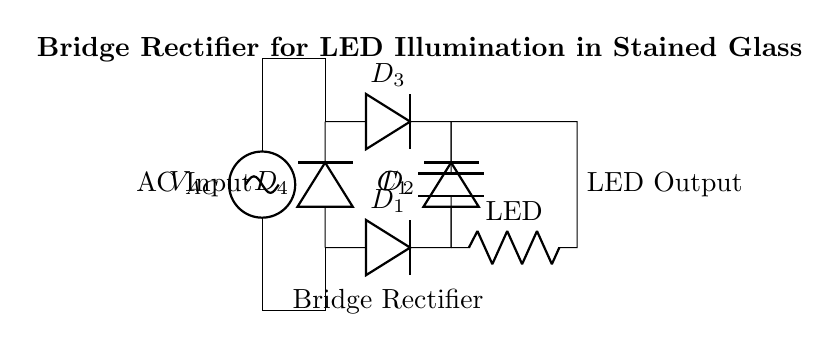What type of rectifier is shown? The circuit diagram depicts a bridge rectifier, which is characterized by four diodes arranged in a bridge configuration to convert AC to DC.
Answer: Bridge rectifier How many diodes are present in the circuit? The circuit includes four diodes: D1, D2, D3, and D4, which are part of the bridge rectifier configuration.
Answer: Four What component smooths the output voltage? The capacitor labeled C1 is responsible for smoothing the output voltage by reducing fluctuations in the rectified DC output.
Answer: Capacitor What is the output load in this circuit? The output load is represented by an LED, which signifies the component being powered by the rectified output.
Answer: LED What is the purpose of the diode in this circuit? The diode's purpose is to allow current to flow in one direction only, thus facilitating the conversion of AC to DC voltage through the rectifier.
Answer: Prevents reverse current How does the bridge rectifier work during one half-cycle? During one half-cycle of AC input, two diodes conduct (e.g., D1 and D2), allowing current to flow through the load, while the other two diodes (D3 and D4) remain off, thereby converting AC to pulsating DC.
Answer: Two diodes conduct What is the significance of the AC input in this circuit? The AC input is the source of alternating current power that needs to be rectified to provide a usable DC output for the LED illumination.
Answer: Provides power source 